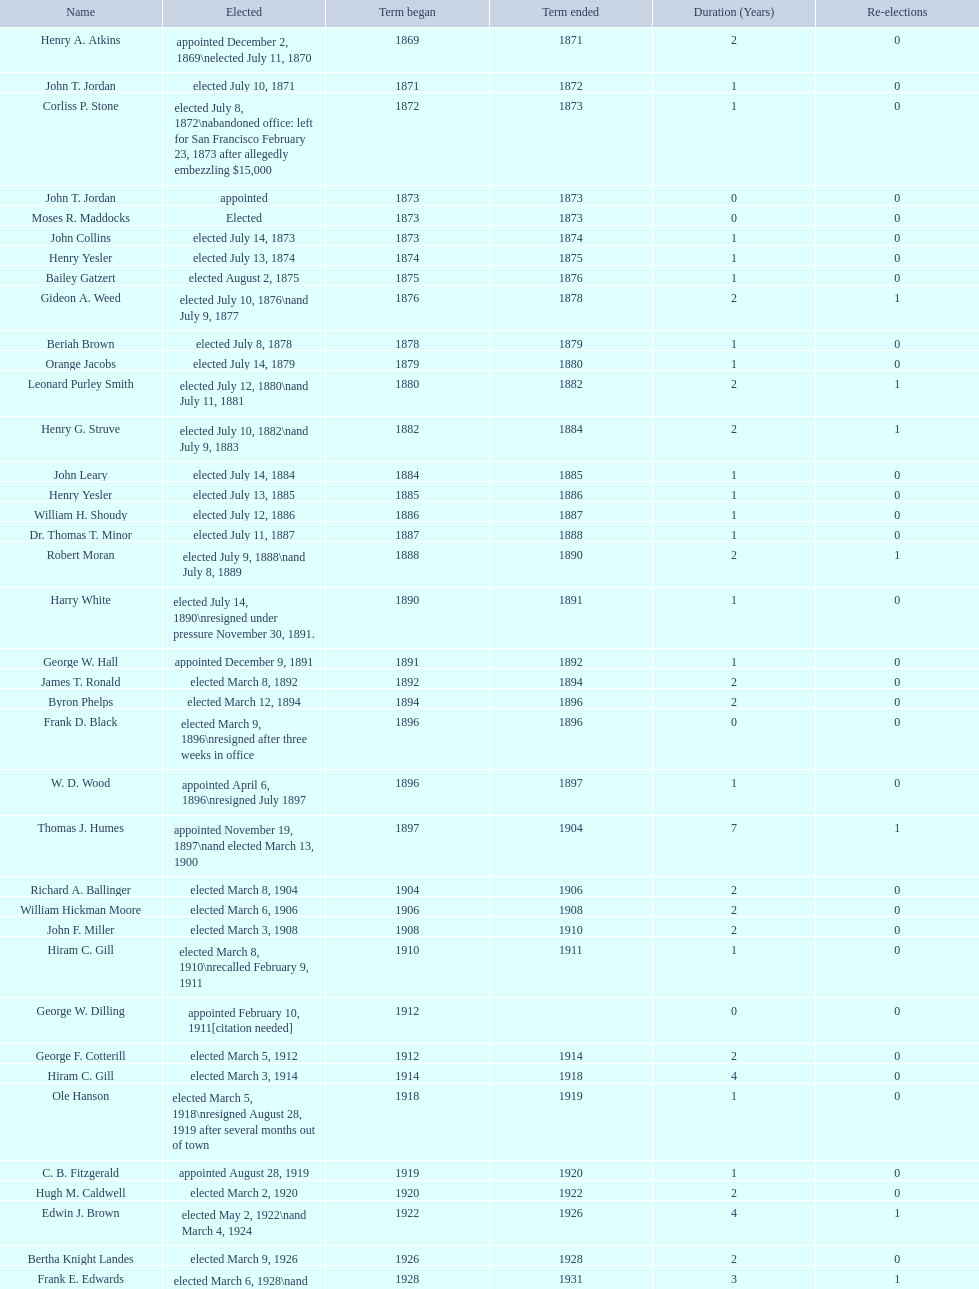Who began their term in 1890? Harry White. 